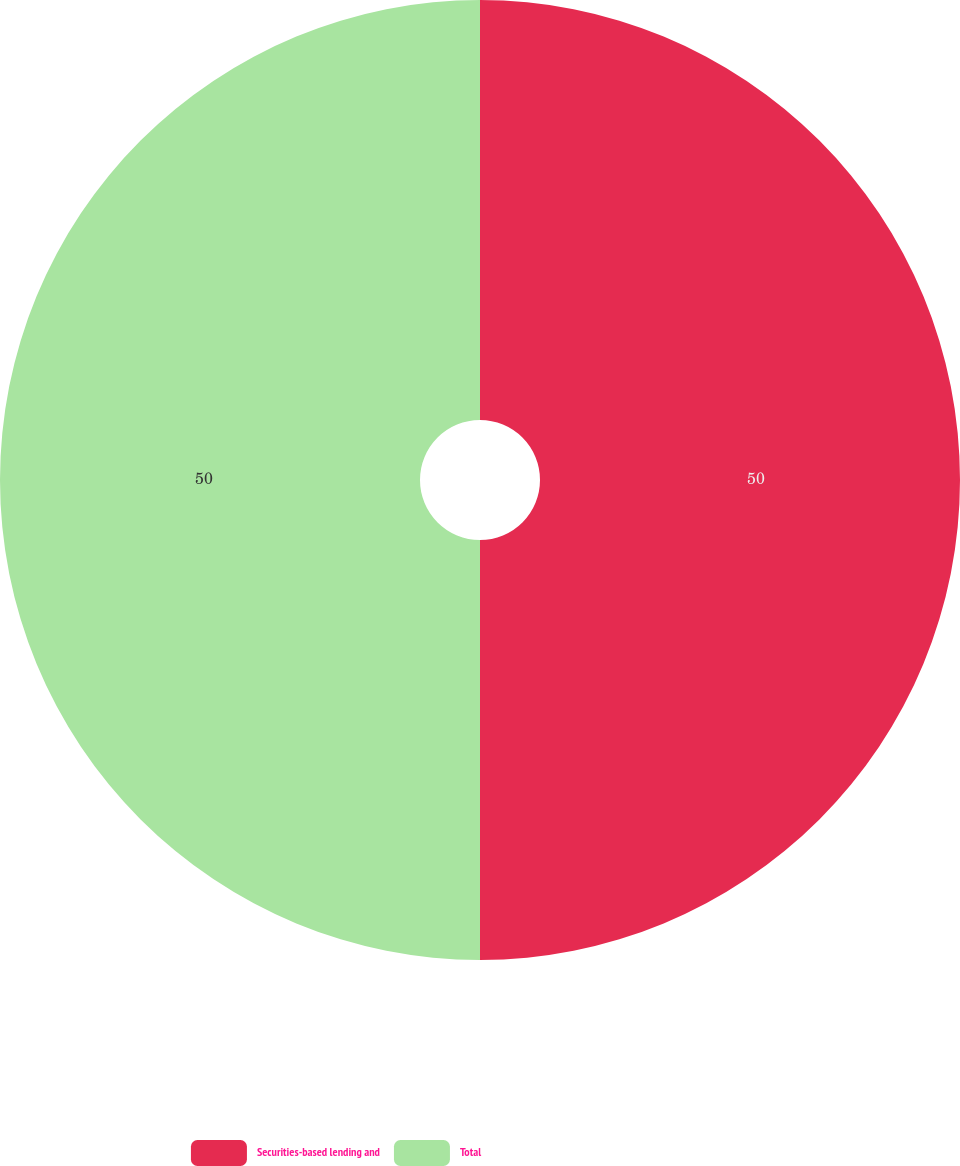Convert chart. <chart><loc_0><loc_0><loc_500><loc_500><pie_chart><fcel>Securities-based lending and<fcel>Total<nl><fcel>50.0%<fcel>50.0%<nl></chart> 